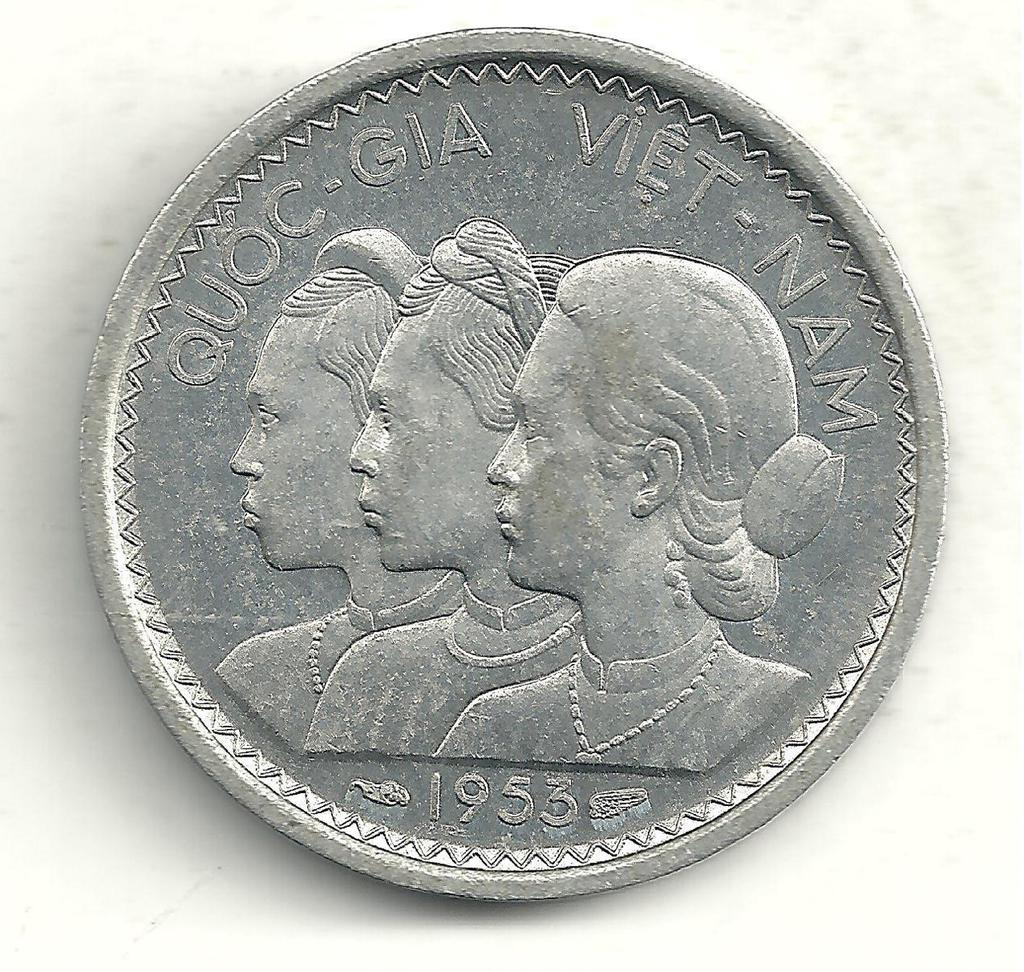<image>
Share a concise interpretation of the image provided. A silver colored coin is imprinted quoc-gia viet-nam, 1953. 